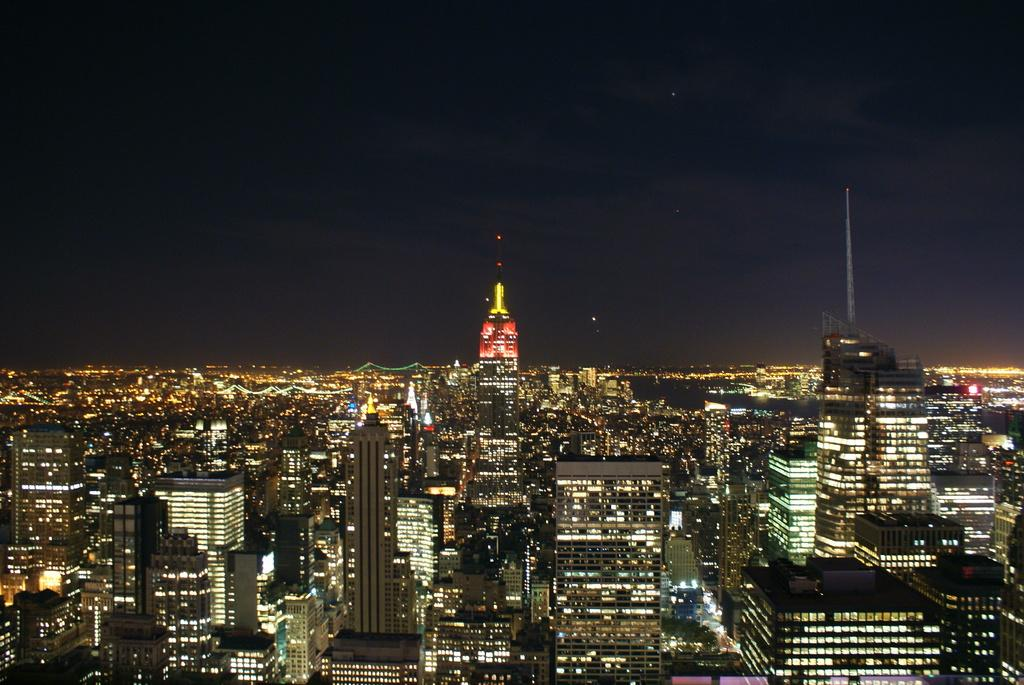What type of structures can be seen in the image? There are buildings in the image, including a skyscraper. What can be seen in the background of the image? The sky is visible in the image. How do the buildings express their anger in the image? Buildings do not express emotions like anger; they are inanimate structures. Are there any dolls present in the image? No, there are no dolls mentioned or visible in the image. 